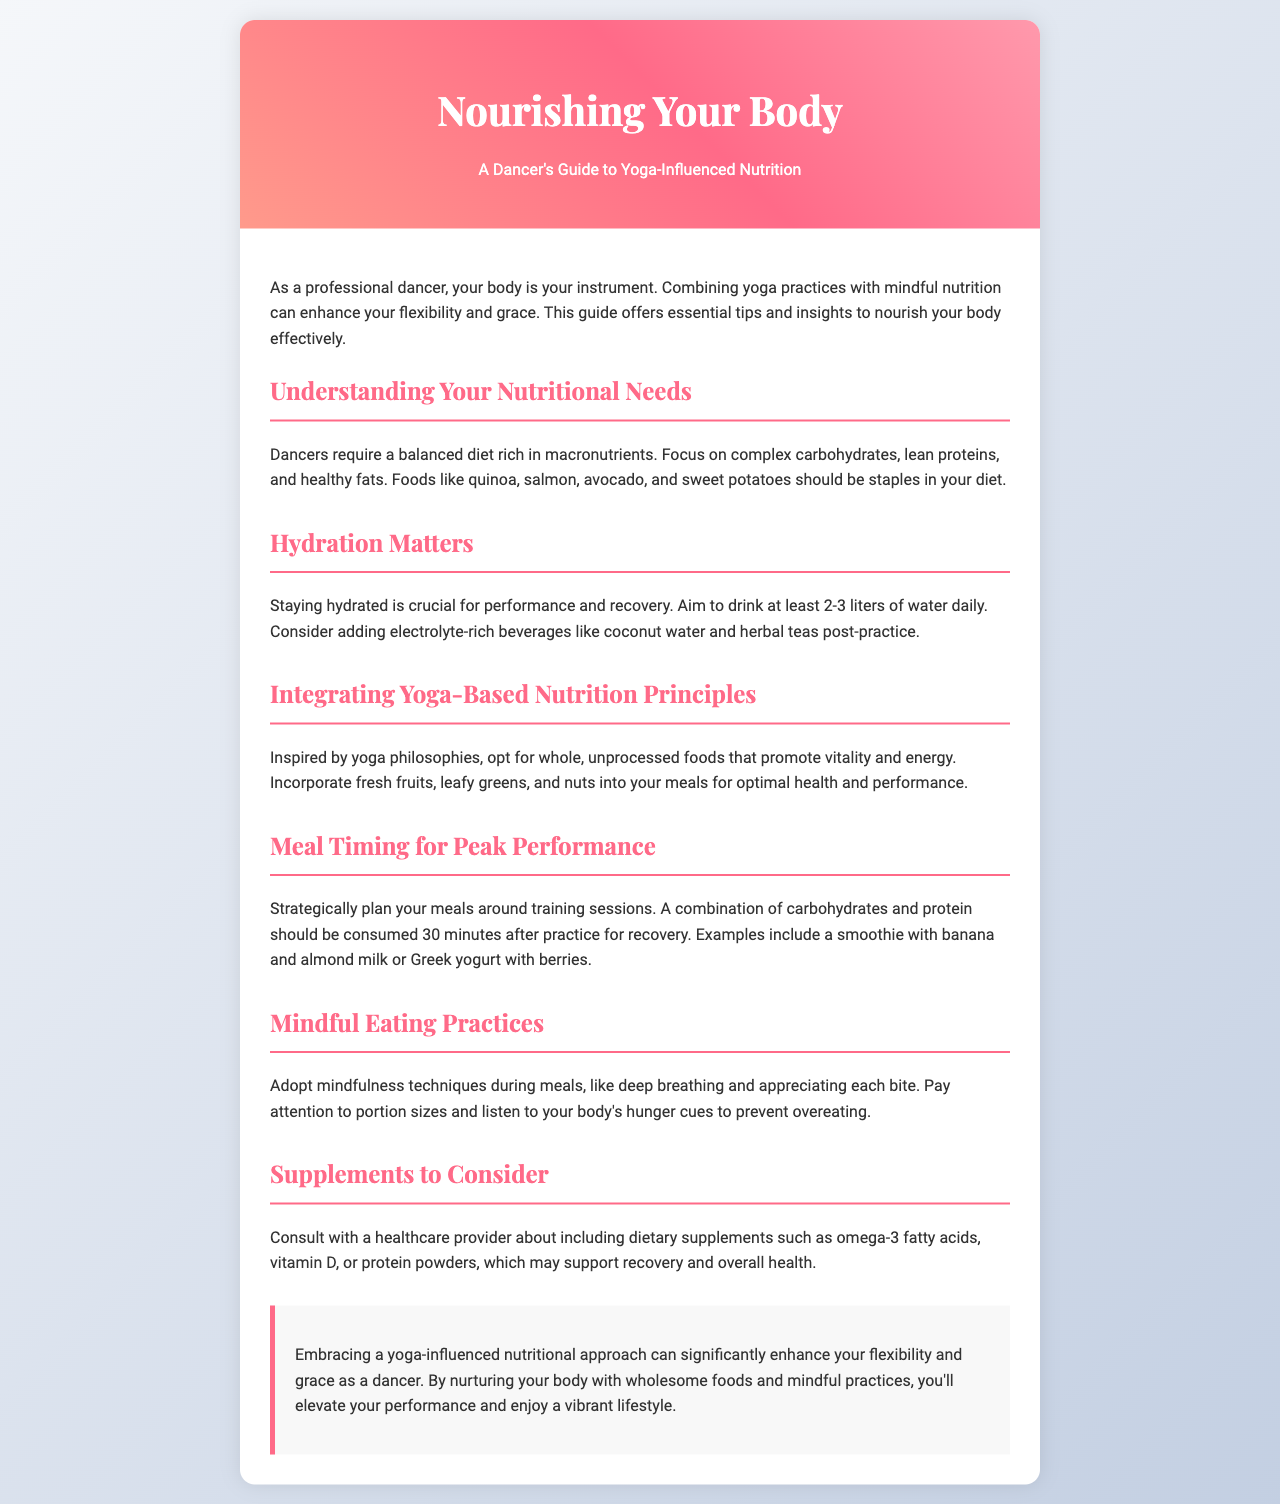What is the title of the brochure? The title of the brochure is provided in the header section of the document.
Answer: Nourishing Your Body: A Dancer's Guide to Yoga-Influenced Nutrition How many liters of water should a dancer aim to drink daily? The document specifies the daily water intake recommendation for dancers under the hydration section.
Answer: 2-3 liters What type of foods should be staples in a dancer's diet? This is mentioned in the section about understanding nutritional needs, which lists specific food types.
Answer: Complex carbohydrates, lean proteins, and healthy fats What is a suggested post-practice recovery option? The document provides an example of a meal to eat after practice within the meal timing section.
Answer: A smoothie with banana and almond milk What kind of mindfulness techniques can be used during meals? This is mentioned in the mindful eating practices section where the document suggests certain techniques.
Answer: Deep breathing What supplements are suggested to consult about? The section on supplements outlines items to consider including in the diet, needing consultation.
Answer: Omega-3 fatty acids, vitamin D, or protein powders What is the main benefit of embracing a yoga-influenced nutritional approach? This benefit is highlighted in the conclusion, summarizing the effects of this approach on dancers.
Answer: Enhance flexibility and grace How can dancers integrate yoga principles into their nutrition? The integration of yoga principles is discussed in a specific section about nutrition principles.
Answer: Whole, unprocessed foods What should be included in meals to promote vitality and energy? The document discusses specific food groups that contribute to vitality in the integrating yoga-based nutrition principles section.
Answer: Fresh fruits, leafy greens, and nuts 